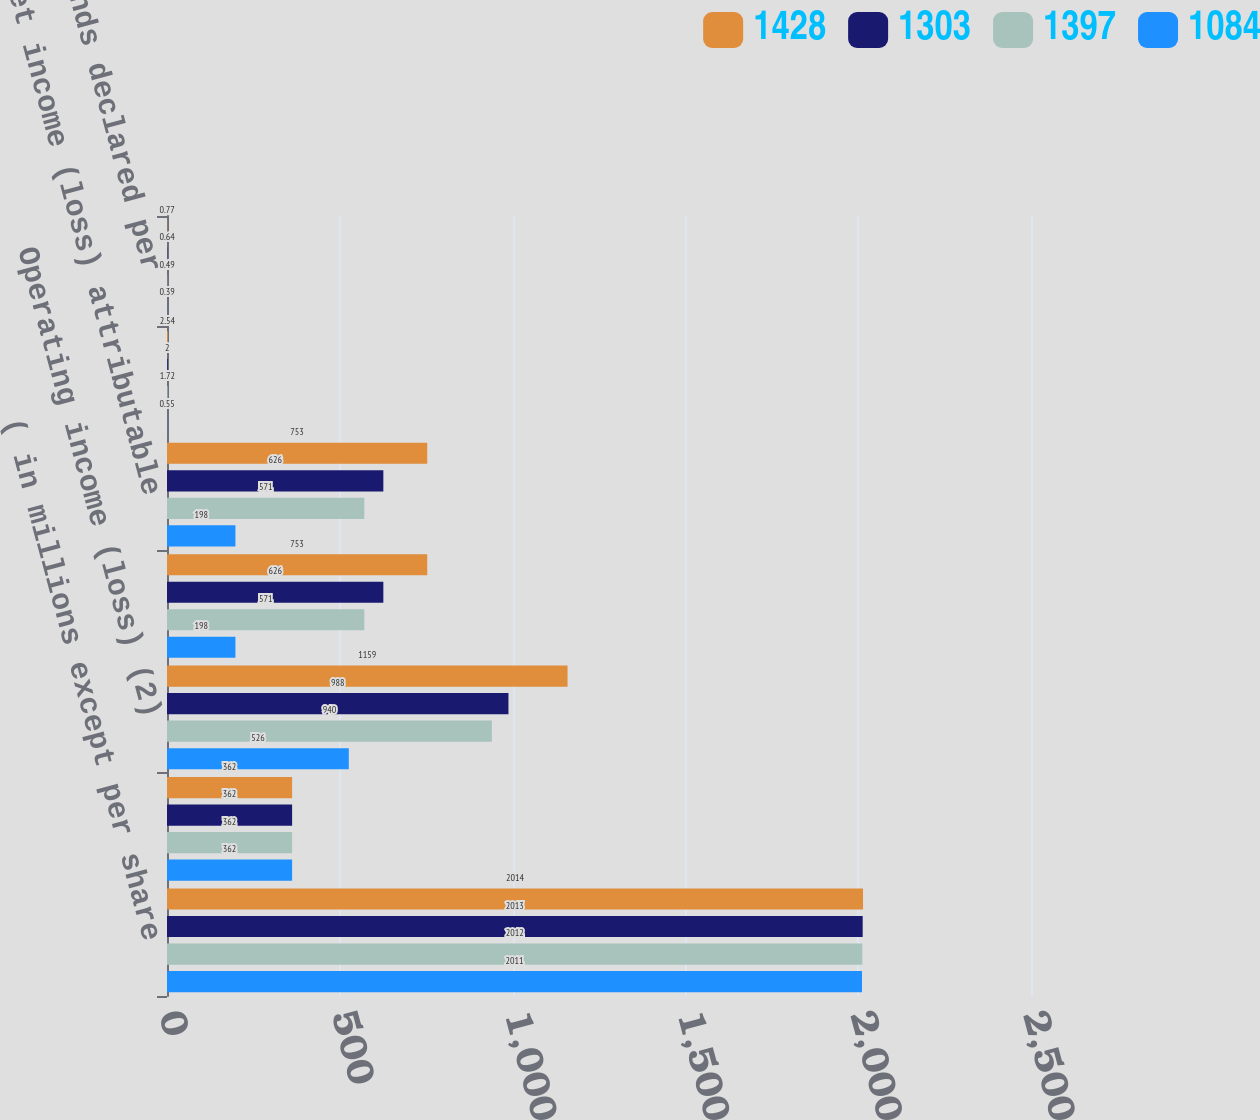<chart> <loc_0><loc_0><loc_500><loc_500><stacked_bar_chart><ecel><fcel>( in millions except per share<fcel>Revenues (2)<fcel>Operating income (loss) (2)<fcel>Income (loss) from continuing<fcel>Net income (loss) attributable<fcel>Diluted earnings (losses) per<fcel>Cash dividends declared per<nl><fcel>1428<fcel>2014<fcel>362<fcel>1159<fcel>753<fcel>753<fcel>2.54<fcel>0.77<nl><fcel>1303<fcel>2013<fcel>362<fcel>988<fcel>626<fcel>626<fcel>2<fcel>0.64<nl><fcel>1397<fcel>2012<fcel>362<fcel>940<fcel>571<fcel>571<fcel>1.72<fcel>0.49<nl><fcel>1084<fcel>2011<fcel>362<fcel>526<fcel>198<fcel>198<fcel>0.55<fcel>0.39<nl></chart> 